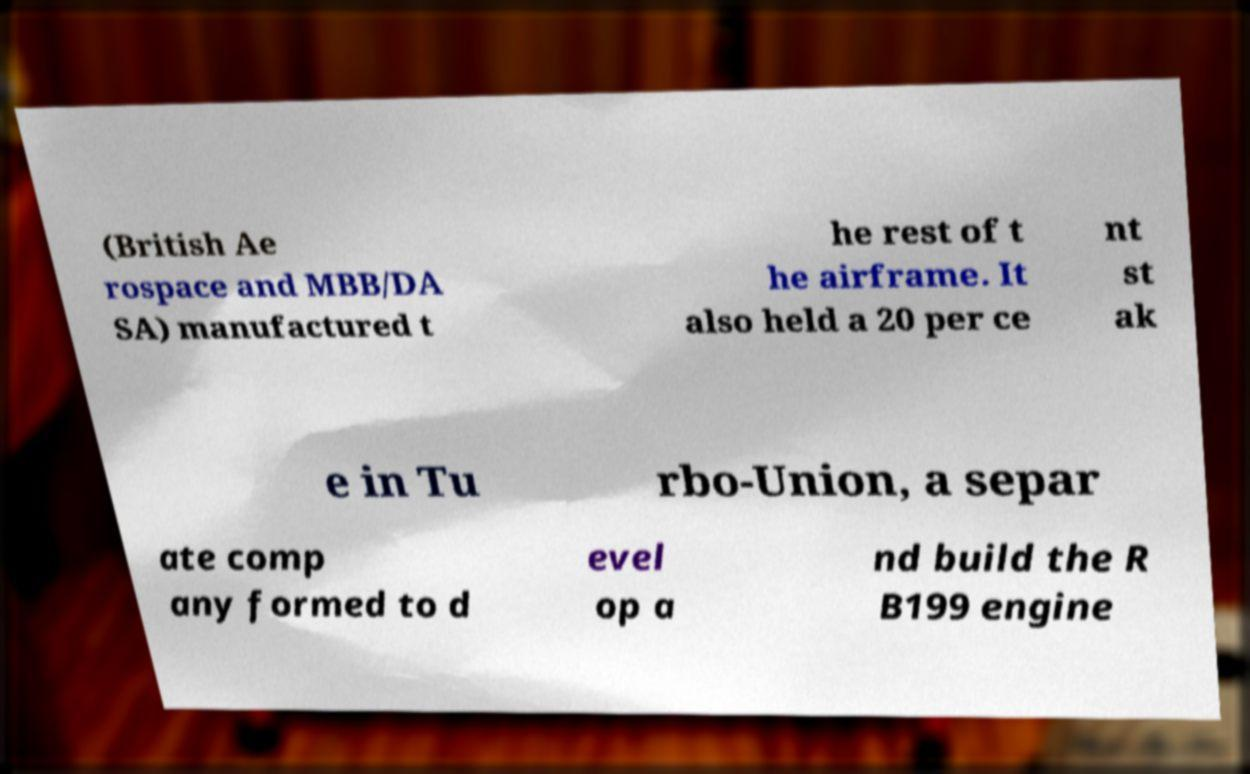For documentation purposes, I need the text within this image transcribed. Could you provide that? (British Ae rospace and MBB/DA SA) manufactured t he rest of t he airframe. It also held a 20 per ce nt st ak e in Tu rbo-Union, a separ ate comp any formed to d evel op a nd build the R B199 engine 